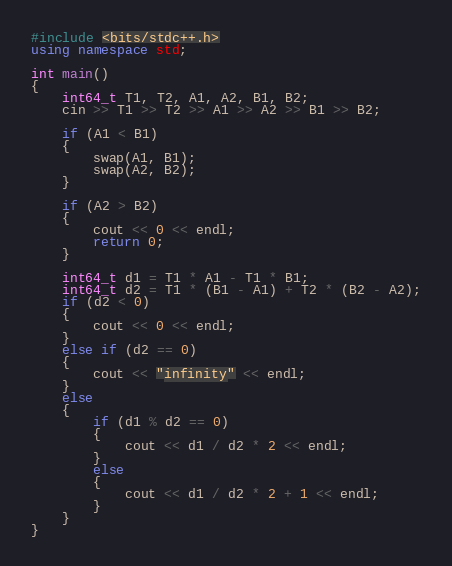Convert code to text. <code><loc_0><loc_0><loc_500><loc_500><_C++_>#include <bits/stdc++.h>
using namespace std;

int main()
{
    int64_t T1, T2, A1, A2, B1, B2;
    cin >> T1 >> T2 >> A1 >> A2 >> B1 >> B2;

    if (A1 < B1)
    {
        swap(A1, B1);
        swap(A2, B2);
    }

    if (A2 > B2)
    {
        cout << 0 << endl;
        return 0;
    }

    int64_t d1 = T1 * A1 - T1 * B1;
    int64_t d2 = T1 * (B1 - A1) + T2 * (B2 - A2);
    if (d2 < 0)
    {
        cout << 0 << endl;
    }
    else if (d2 == 0)
    {
        cout << "infinity" << endl;
    }
    else
    {
        if (d1 % d2 == 0)
        {
            cout << d1 / d2 * 2 << endl;
        }
        else
        {
            cout << d1 / d2 * 2 + 1 << endl;
        }
    }
}</code> 